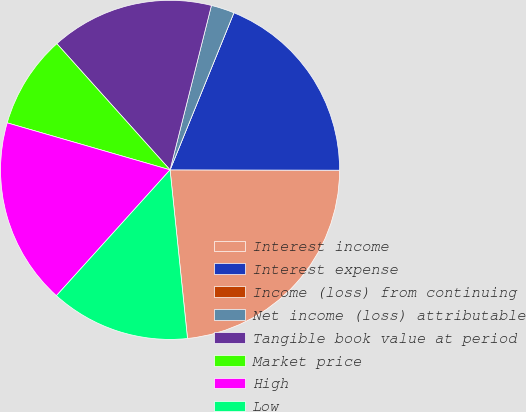Convert chart. <chart><loc_0><loc_0><loc_500><loc_500><pie_chart><fcel>Interest income<fcel>Interest expense<fcel>Income (loss) from continuing<fcel>Net income (loss) attributable<fcel>Tangible book value at period<fcel>Market price<fcel>High<fcel>Low<nl><fcel>23.33%<fcel>18.89%<fcel>0.0%<fcel>2.22%<fcel>15.56%<fcel>8.89%<fcel>17.78%<fcel>13.33%<nl></chart> 